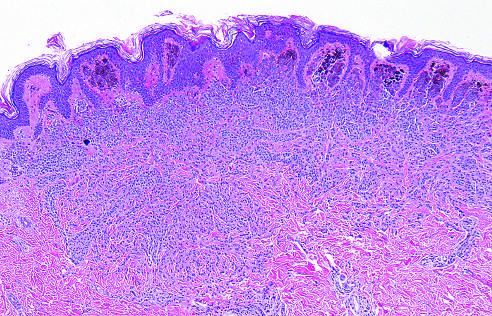s the photomicrograph of pheochromocytoma composed of melanocytes that lose pigmentation and become smaller and more dispersed as they extend into the dermis-all signs that speak to the benign nature of the proliferation?
Answer the question using a single word or phrase. No 